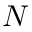<formula> <loc_0><loc_0><loc_500><loc_500>N</formula> 